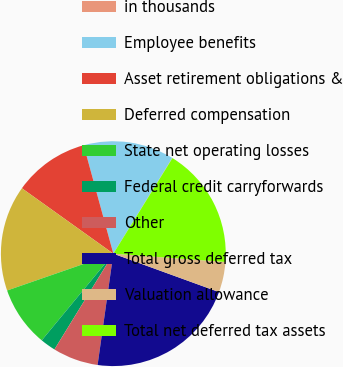Convert chart. <chart><loc_0><loc_0><loc_500><loc_500><pie_chart><fcel>in thousands<fcel>Employee benefits<fcel>Asset retirement obligations &<fcel>Deferred compensation<fcel>State net operating losses<fcel>Federal credit carryforwards<fcel>Other<fcel>Total gross deferred tax<fcel>Valuation allowance<fcel>Total net deferred tax assets<nl><fcel>0.04%<fcel>13.03%<fcel>10.87%<fcel>15.2%<fcel>8.7%<fcel>2.21%<fcel>6.54%<fcel>21.69%<fcel>4.37%<fcel>17.36%<nl></chart> 